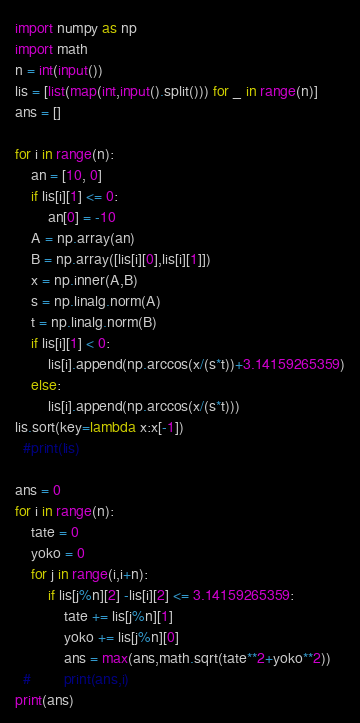Convert code to text. <code><loc_0><loc_0><loc_500><loc_500><_Python_>import numpy as np
import math
n = int(input())
lis = [list(map(int,input().split())) for _ in range(n)]
ans = []

for i in range(n):
    an = [10, 0]
    if lis[i][1] <= 0:
        an[0] = -10
    A = np.array(an)
    B = np.array([lis[i][0],lis[i][1]])
    x = np.inner(A,B)
    s = np.linalg.norm(A)
    t = np.linalg.norm(B)
    if lis[i][1] < 0:
        lis[i].append(np.arccos(x/(s*t))+3.14159265359)
    else:
        lis[i].append(np.arccos(x/(s*t)))
lis.sort(key=lambda x:x[-1])
  #print(lis)

ans = 0
for i in range(n):
    tate = 0
    yoko = 0
    for j in range(i,i+n):
        if lis[j%n][2] -lis[i][2] <= 3.14159265359:
            tate += lis[j%n][1]
            yoko += lis[j%n][0]
            ans = max(ans,math.sqrt(tate**2+yoko**2))
  #        print(ans,i)
print(ans)
</code> 